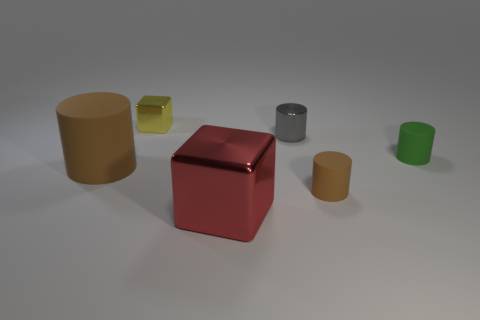Add 4 brown rubber spheres. How many objects exist? 10 Subtract all tiny green matte cylinders. How many cylinders are left? 3 Subtract all yellow blocks. How many blocks are left? 1 Subtract 2 cylinders. How many cylinders are left? 2 Subtract 0 purple spheres. How many objects are left? 6 Subtract all cylinders. How many objects are left? 2 Subtract all gray cubes. Subtract all gray cylinders. How many cubes are left? 2 Subtract all blue blocks. How many red cylinders are left? 0 Subtract all large rubber cylinders. Subtract all tiny cubes. How many objects are left? 4 Add 3 yellow cubes. How many yellow cubes are left? 4 